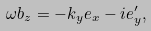<formula> <loc_0><loc_0><loc_500><loc_500>\omega b _ { z } = - k _ { y } e _ { x } - i e _ { y } ^ { \prime } ,</formula> 